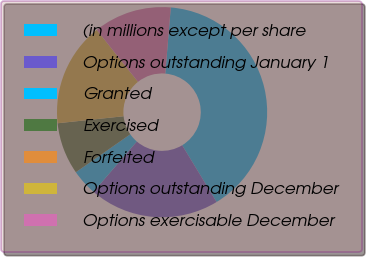Convert chart to OTSL. <chart><loc_0><loc_0><loc_500><loc_500><pie_chart><fcel>(in millions except per share<fcel>Options outstanding January 1<fcel>Granted<fcel>Exercised<fcel>Forfeited<fcel>Options outstanding December<fcel>Options exercisable December<nl><fcel>40.0%<fcel>20.0%<fcel>4.0%<fcel>8.0%<fcel>0.0%<fcel>16.0%<fcel>12.0%<nl></chart> 